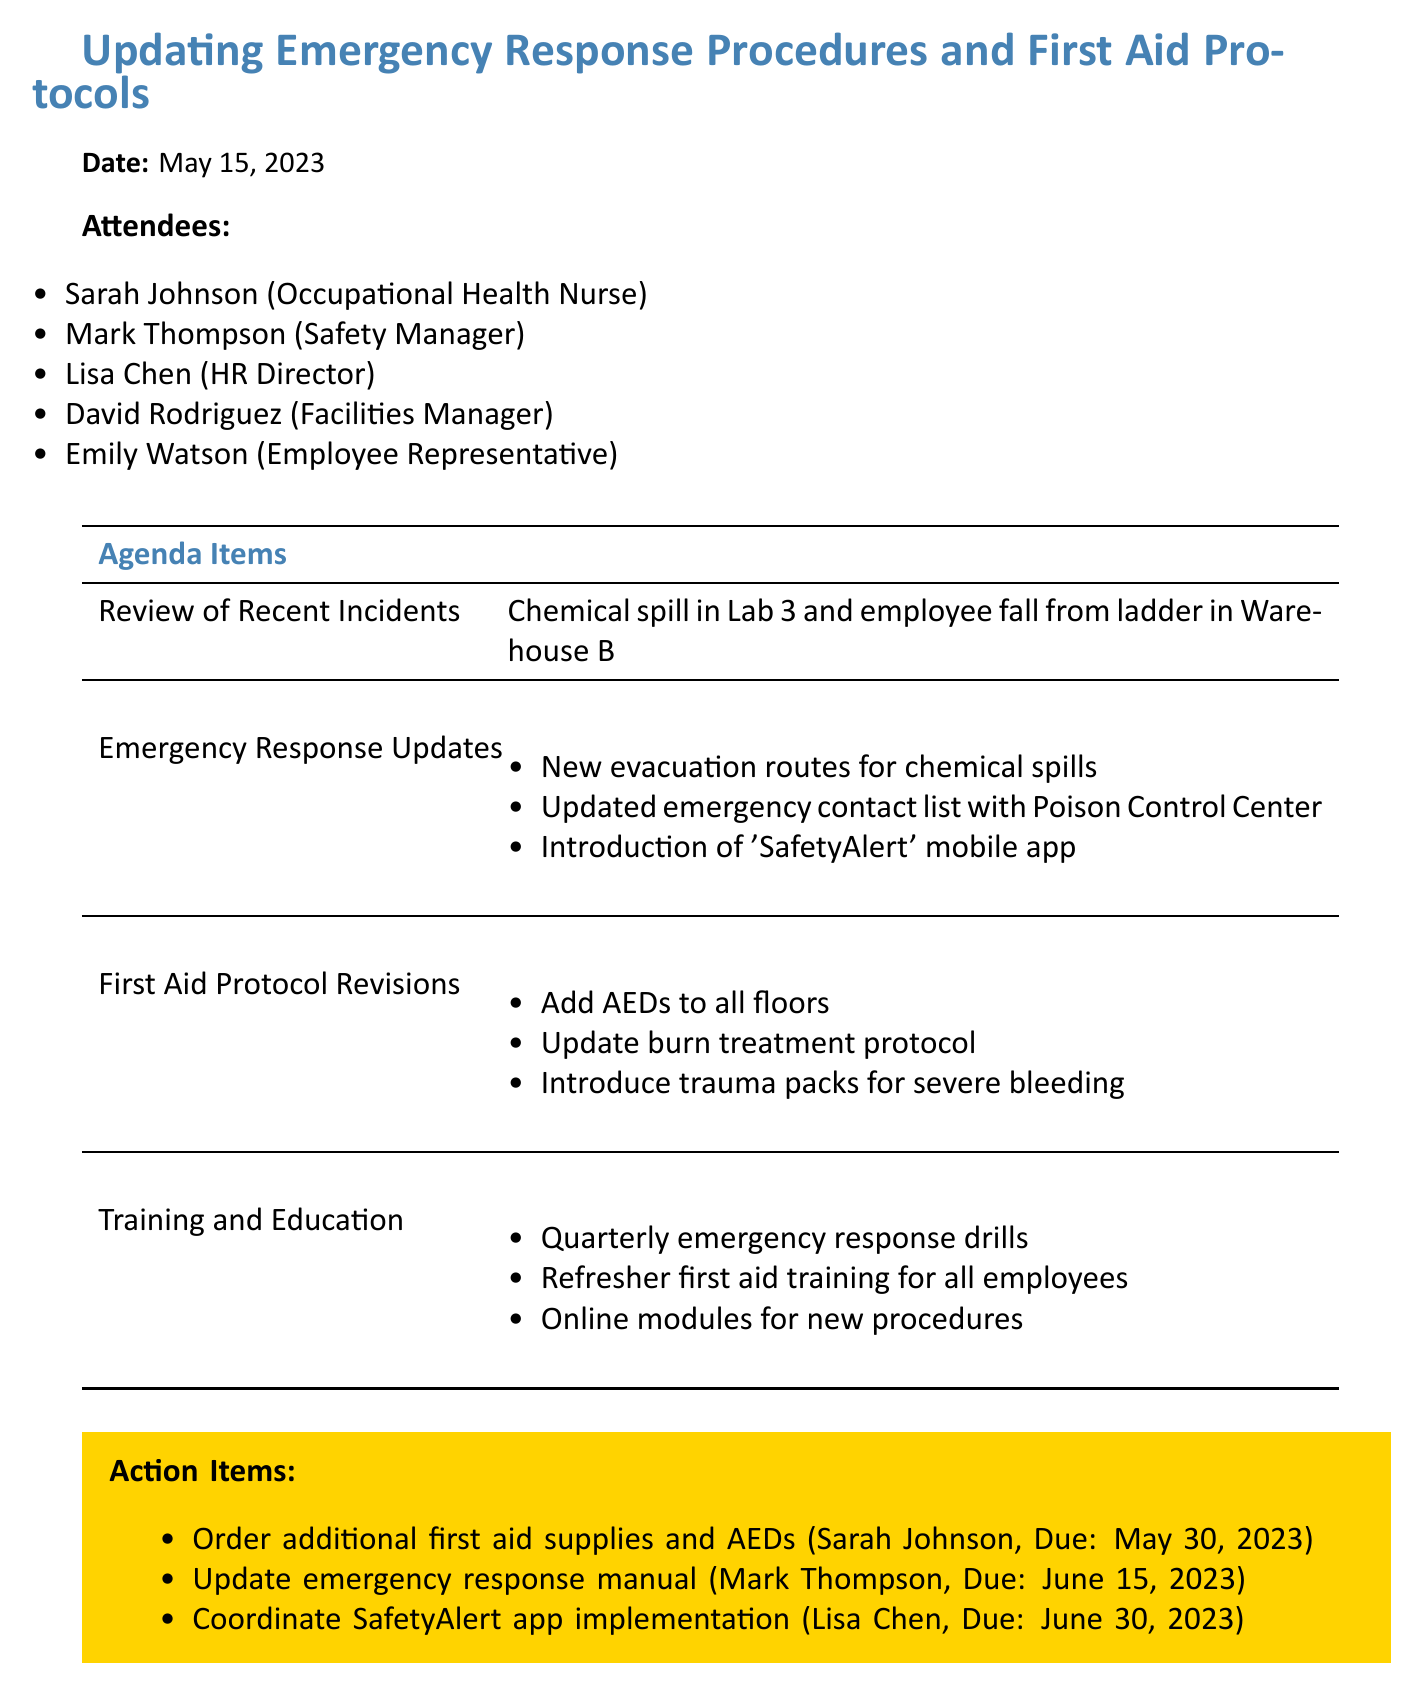What is the date of the meeting? The date of the meeting is clearly stated in the document.
Answer: May 15, 2023 Who is the Occupational Health Nurse in the meeting? The document lists attendees, including the Occupational Health Nurse.
Answer: Sarah Johnson What were the two recent workplace incidents discussed? The meeting minutes detail two specific incidents.
Answer: Chemical spill in Lab 3 and employee fall from ladder in Warehouse B What item is due to be ordered by May 30, 2023? One of the action items specifies what is to be ordered and its due date.
Answer: Additional first aid supplies and AEDs Who is responsible for updating the emergency response manual? The action items list the responsibilities assigned to attendees, identifying who handles updates.
Answer: Mark Thompson What is one update to the first aid protocol? The document outlines several revisions to the first aid protocol.
Answer: Add automated external defibrillators (AEDs) to all floors How many emergency response drills are scheduled per year? The training and education section specifies the frequency of drills.
Answer: Quarterly What mobile app was introduced for emergencies? The document mentions a specific mobile app intended for communication during emergencies.
Answer: SafetyAlert 